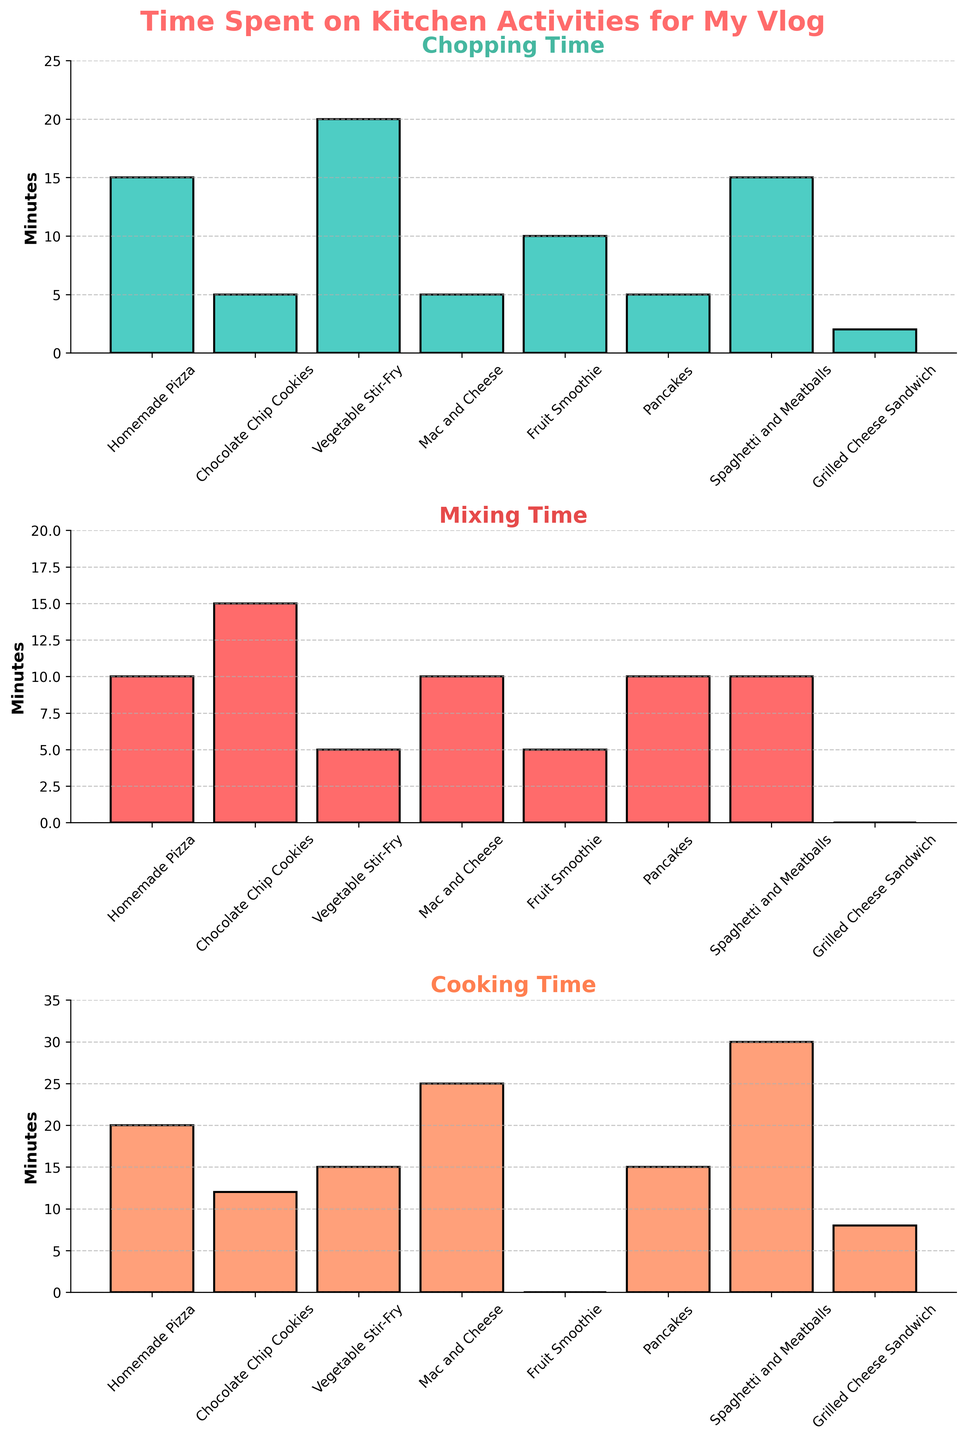What is the title of the figure? The title can be found at the top of the figure, which is "Time Spent on Kitchen Activities for My Vlog"
Answer: Time Spent on Kitchen Activities for My Vlog What is the maximum time spent chopping for any activity? In the first sub-plot showing chopping time, the tallest bar represents the maximum time. This is for Vegetable Stir-Fry at 20 minutes.
Answer: 20 minutes Which activity has the least mixing time? In the second sub-plot showing mixing time, the shortest bar indicates the least time, which is for Grilled Cheese Sandwich at 0 minutes.
Answer: Grilled Cheese Sandwich What is the total time spent on making Homemade Pizza? The total time is the sum of chopping, mixing, and cooking times for Homemade Pizza. Add 15 (chopping) + 10 (mixing) + 20 (cooking) which equals 45 minutes.
Answer: 45 minutes Between Pancakes and Fruit Smoothie, which activity has more chopping time? In the first sub-plot, compare the heights of the bars for Pancakes and Fruit Smoothie. Fruit Smoothie has 10 minutes, whereas Pancakes have 5 minutes.
Answer: Fruit Smoothie Which activity requires more time, Mac and Cheese or Spaghetti and Meatballs? Calculate the total time by summing chopping, mixing, and cooking times: 
- Mac and Cheese: 5 (chopping) + 10 (mixing) + 25 (cooking) = 40 minutes
- Spaghetti and Meatballs: 15 (chopping) + 10 (mixing) + 30 (cooking) = 55 minutes
Therefore, Spaghetti and Meatballs require more time.
Answer: Spaghetti and Meatballs What is the average cooking time across all activities? Sum the cooking times for all activities and divide by the number of activities. 
(20 + 12 + 15 + 25 + 0 + 15 + 30 + 8) minutes = 125 minutes.
There are 8 activities, so the average is 125/8 = 15.625 minutes.
Answer: 15.625 minutes 